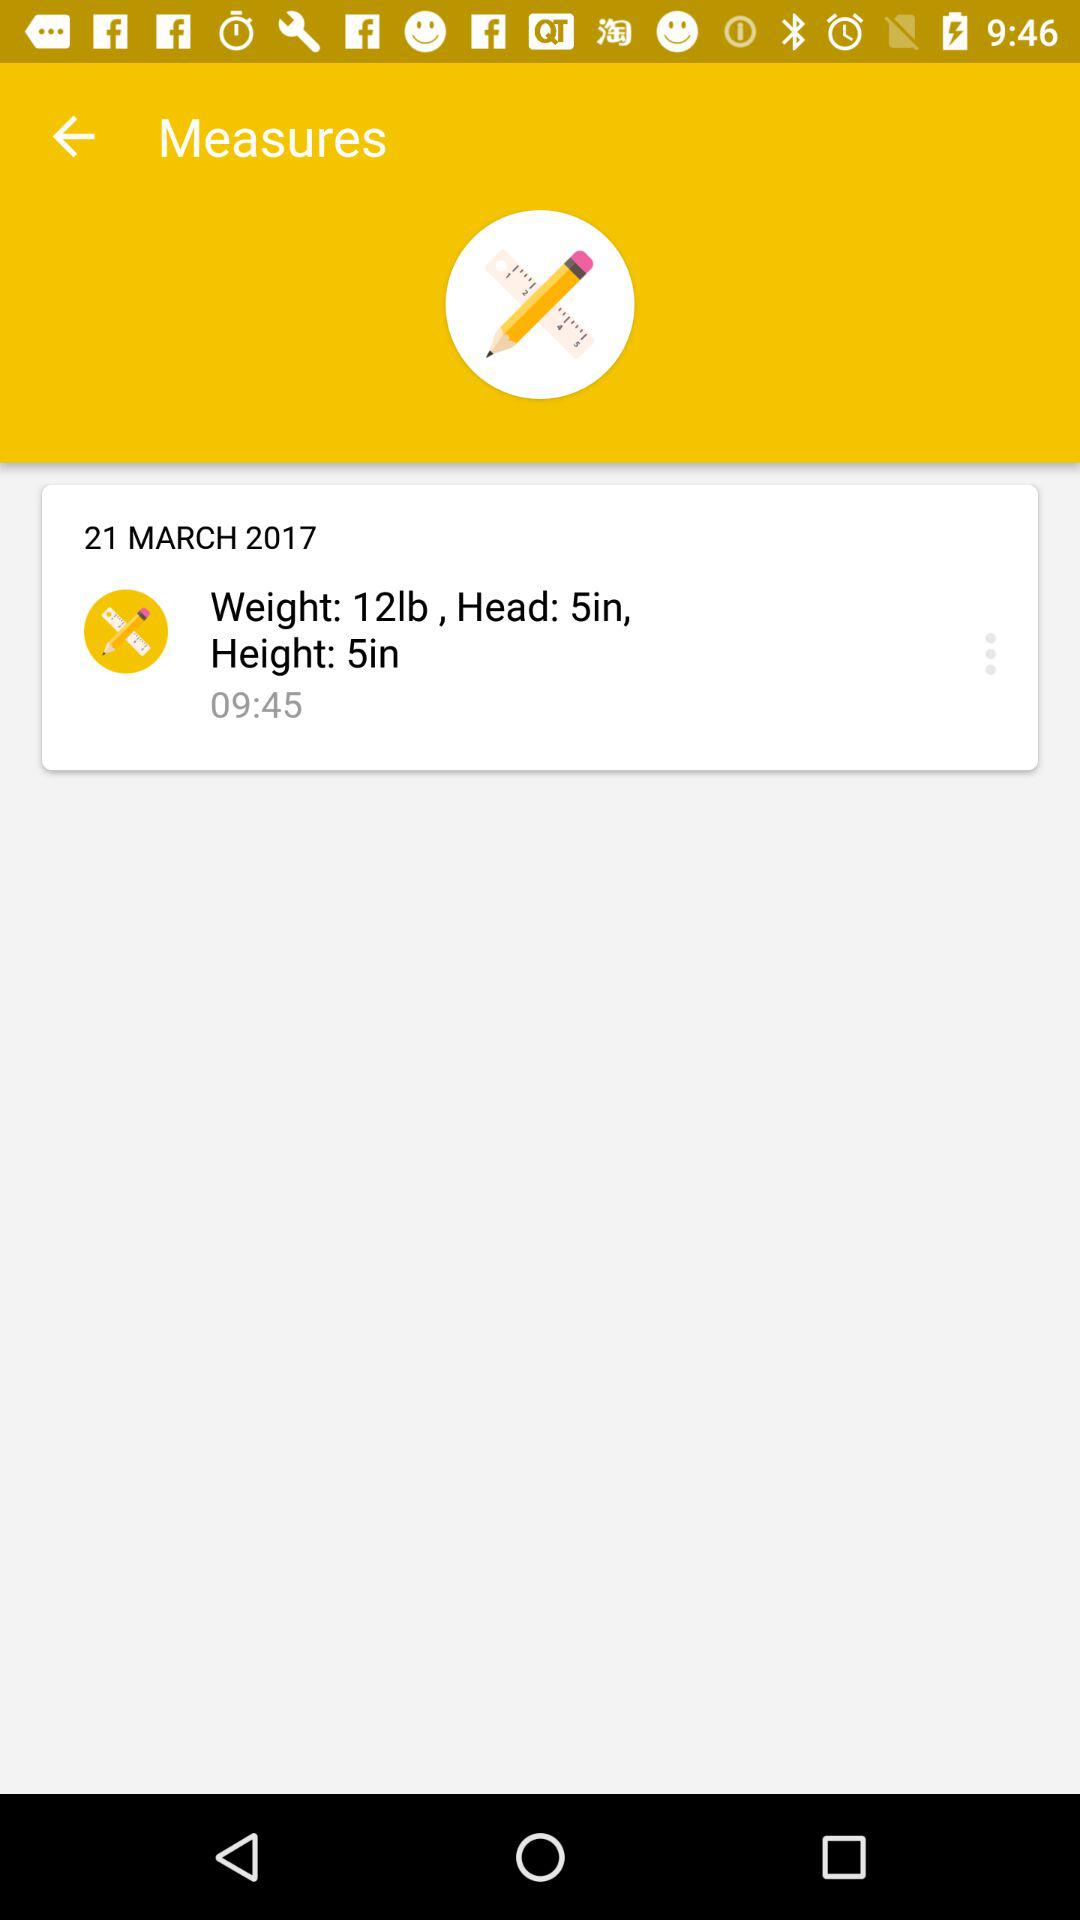What is the size of the head? The size of the head is 5 inches. 